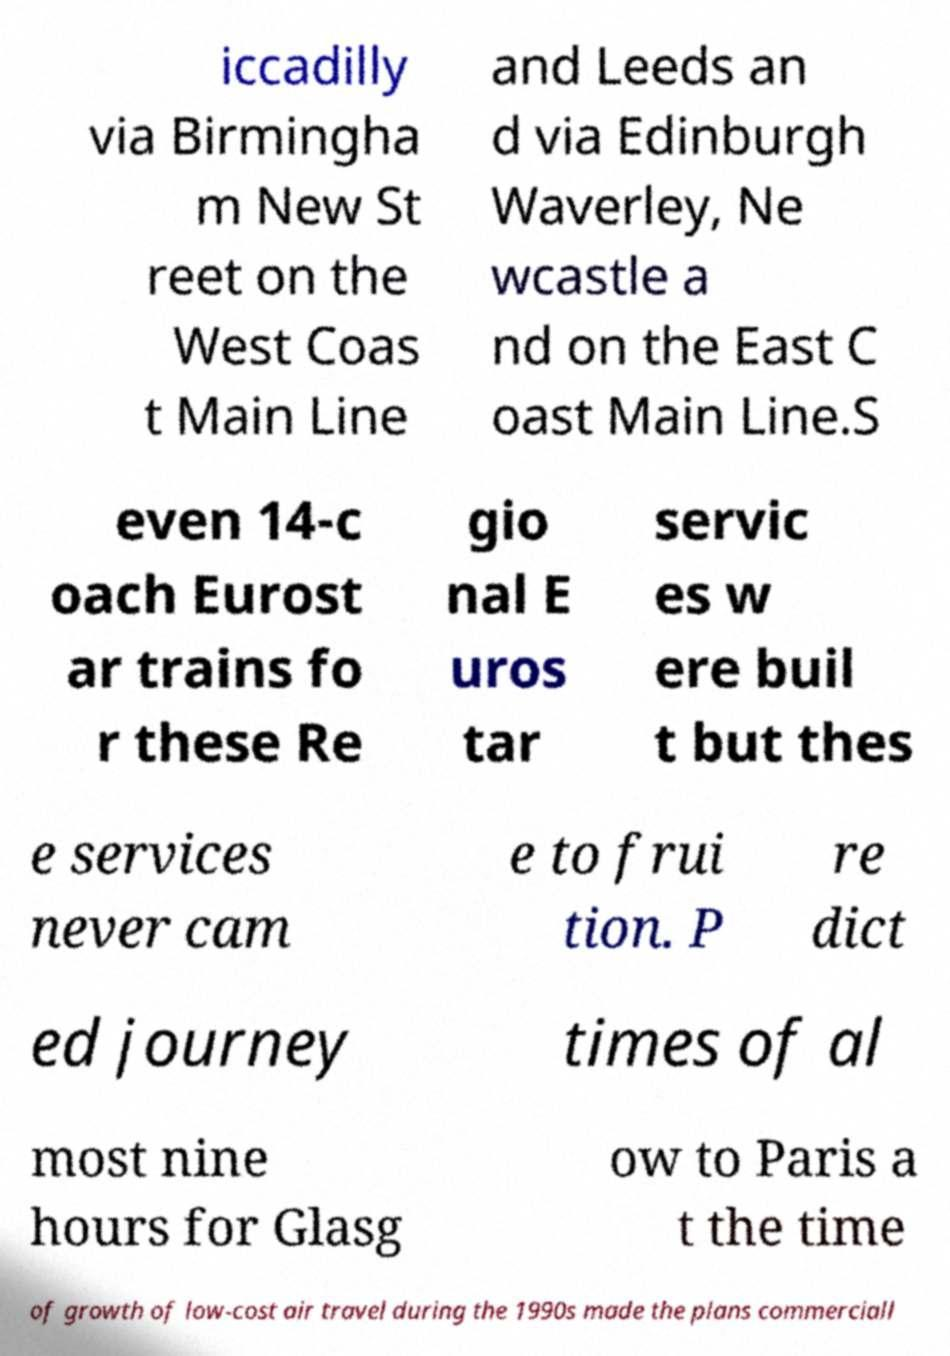Could you assist in decoding the text presented in this image and type it out clearly? iccadilly via Birmingha m New St reet on the West Coas t Main Line and Leeds an d via Edinburgh Waverley, Ne wcastle a nd on the East C oast Main Line.S even 14-c oach Eurost ar trains fo r these Re gio nal E uros tar servic es w ere buil t but thes e services never cam e to frui tion. P re dict ed journey times of al most nine hours for Glasg ow to Paris a t the time of growth of low-cost air travel during the 1990s made the plans commerciall 